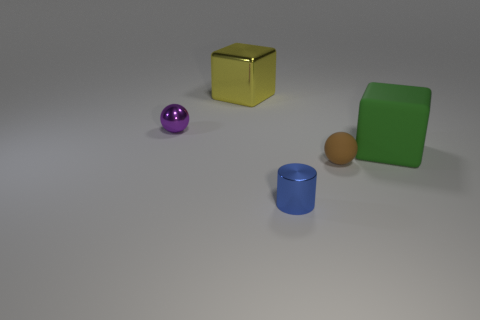There is a green matte object that is the same shape as the big metallic thing; what size is it?
Give a very brief answer. Large. Is the color of the metallic object in front of the big green thing the same as the tiny sphere to the right of the large yellow block?
Your answer should be compact. No. Is the number of matte objects that are behind the purple thing greater than the number of purple metal objects?
Your answer should be compact. No. What is the green cube made of?
Provide a succinct answer. Rubber. There is a purple object that is the same material as the tiny cylinder; what shape is it?
Keep it short and to the point. Sphere. What size is the object to the right of the tiny ball on the right side of the purple object?
Provide a short and direct response. Large. What is the color of the large block in front of the large metal cube?
Your answer should be very brief. Green. Is there a big yellow thing of the same shape as the small blue object?
Offer a very short reply. No. Are there fewer yellow metal cubes that are to the right of the large yellow cube than small brown rubber things on the left side of the brown matte thing?
Offer a very short reply. No. The shiny cube has what color?
Give a very brief answer. Yellow. 